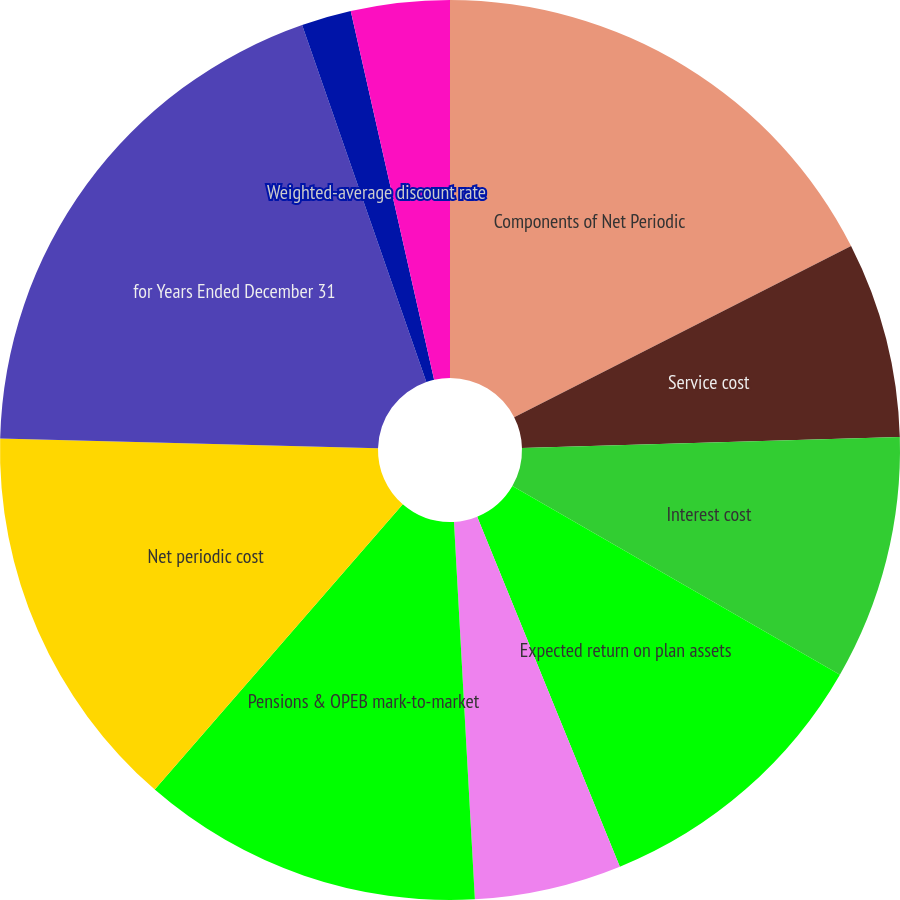<chart> <loc_0><loc_0><loc_500><loc_500><pie_chart><fcel>Components of Net Periodic<fcel>Service cost<fcel>Interest cost<fcel>Expected return on plan assets<fcel>Amortization of prior service<fcel>Pensions & OPEB mark-to-market<fcel>Net periodic cost<fcel>for Years Ended December 31<fcel>Weighted-average discount rate<fcel>Expected long-term return on<nl><fcel>17.51%<fcel>7.03%<fcel>8.78%<fcel>10.52%<fcel>5.28%<fcel>12.27%<fcel>14.02%<fcel>19.26%<fcel>1.79%<fcel>3.54%<nl></chart> 